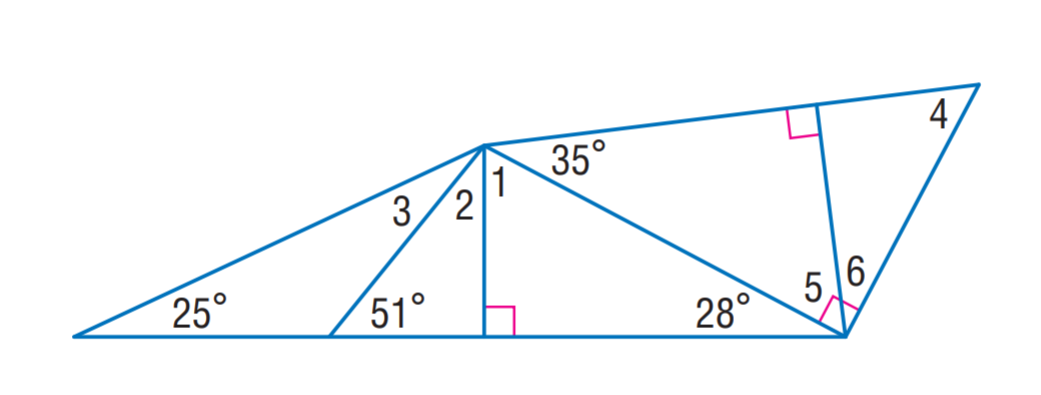Answer the mathemtical geometry problem and directly provide the correct option letter.
Question: Find m \angle 2.
Choices: A: 26 B: 39 C: 55 D: 62 B 